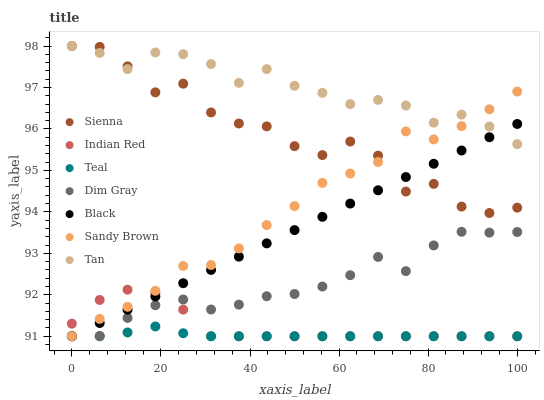Does Teal have the minimum area under the curve?
Answer yes or no. Yes. Does Tan have the maximum area under the curve?
Answer yes or no. Yes. Does Indian Red have the minimum area under the curve?
Answer yes or no. No. Does Indian Red have the maximum area under the curve?
Answer yes or no. No. Is Black the smoothest?
Answer yes or no. Yes. Is Sienna the roughest?
Answer yes or no. Yes. Is Indian Red the smoothest?
Answer yes or no. No. Is Indian Red the roughest?
Answer yes or no. No. Does Dim Gray have the lowest value?
Answer yes or no. Yes. Does Sienna have the lowest value?
Answer yes or no. No. Does Tan have the highest value?
Answer yes or no. Yes. Does Indian Red have the highest value?
Answer yes or no. No. Is Dim Gray less than Sienna?
Answer yes or no. Yes. Is Sienna greater than Indian Red?
Answer yes or no. Yes. Does Black intersect Tan?
Answer yes or no. Yes. Is Black less than Tan?
Answer yes or no. No. Is Black greater than Tan?
Answer yes or no. No. Does Dim Gray intersect Sienna?
Answer yes or no. No. 